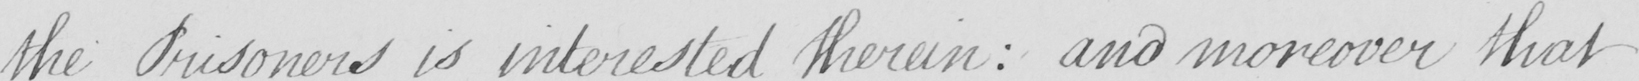Please provide the text content of this handwritten line. the Prisoners is interested therein  :  and moreover that 